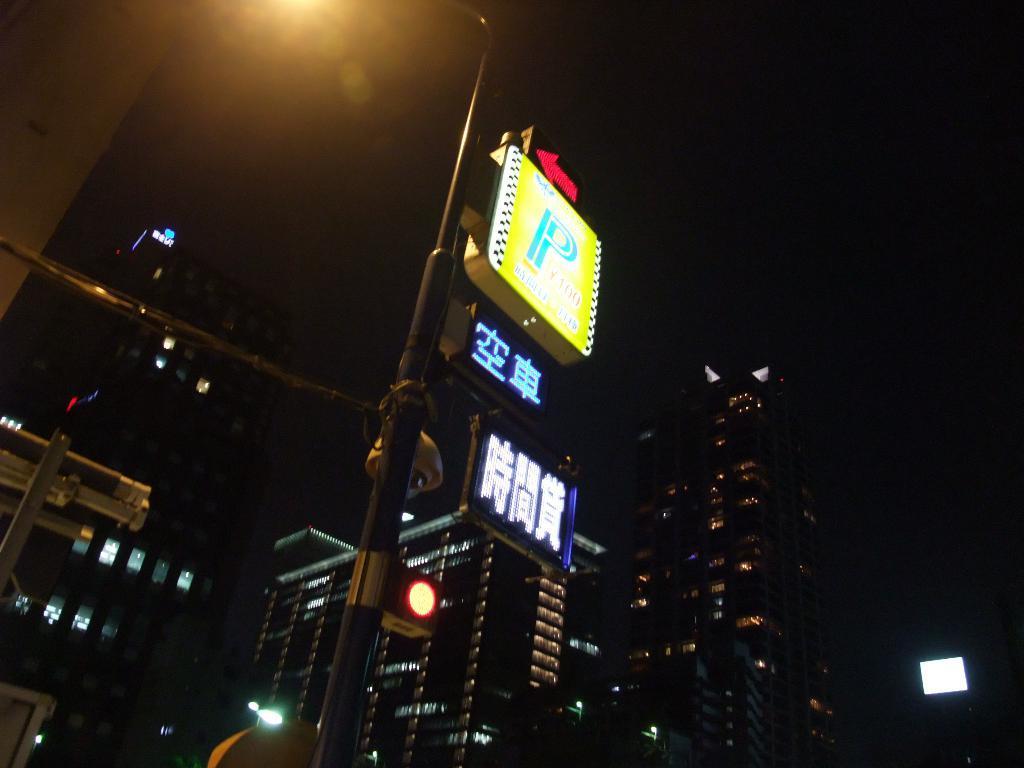Describe this image in one or two sentences. In this image we can see many buildings. There are few street lights in the image. There are few advertising boards in the image. There is a directional board and a traffic light in the image. 